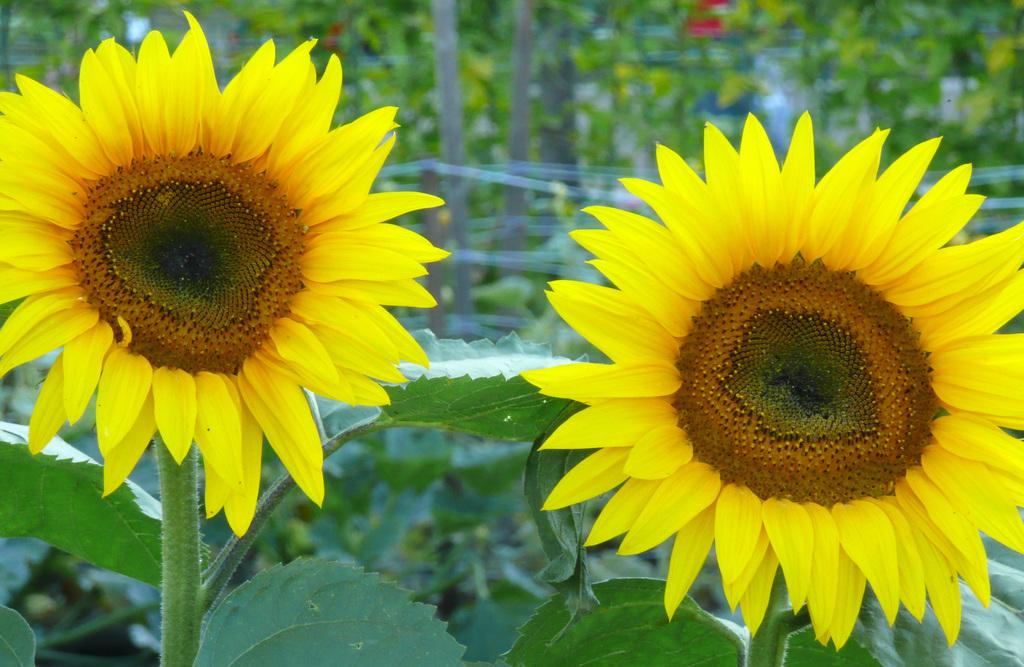How many sunflowers are in the image? There are two sunflowers in the image. What are the sunflowers growing on? The sunflowers are on plants. What other types of plants can be seen in the image? There are other plants visible in the image. What else can be seen in the background of the image? There are trees visible in the image, although they appear blurry. How many books are stacked on the sunflowers in the image? There are no books present in the image; it features sunflowers and other plants. 